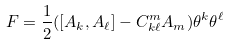Convert formula to latex. <formula><loc_0><loc_0><loc_500><loc_500>F = \frac { 1 } { 2 } ( [ A _ { k } , A _ { \ell } ] - C ^ { m } _ { k \ell } A _ { m } ) \theta ^ { k } \theta ^ { \ell }</formula> 